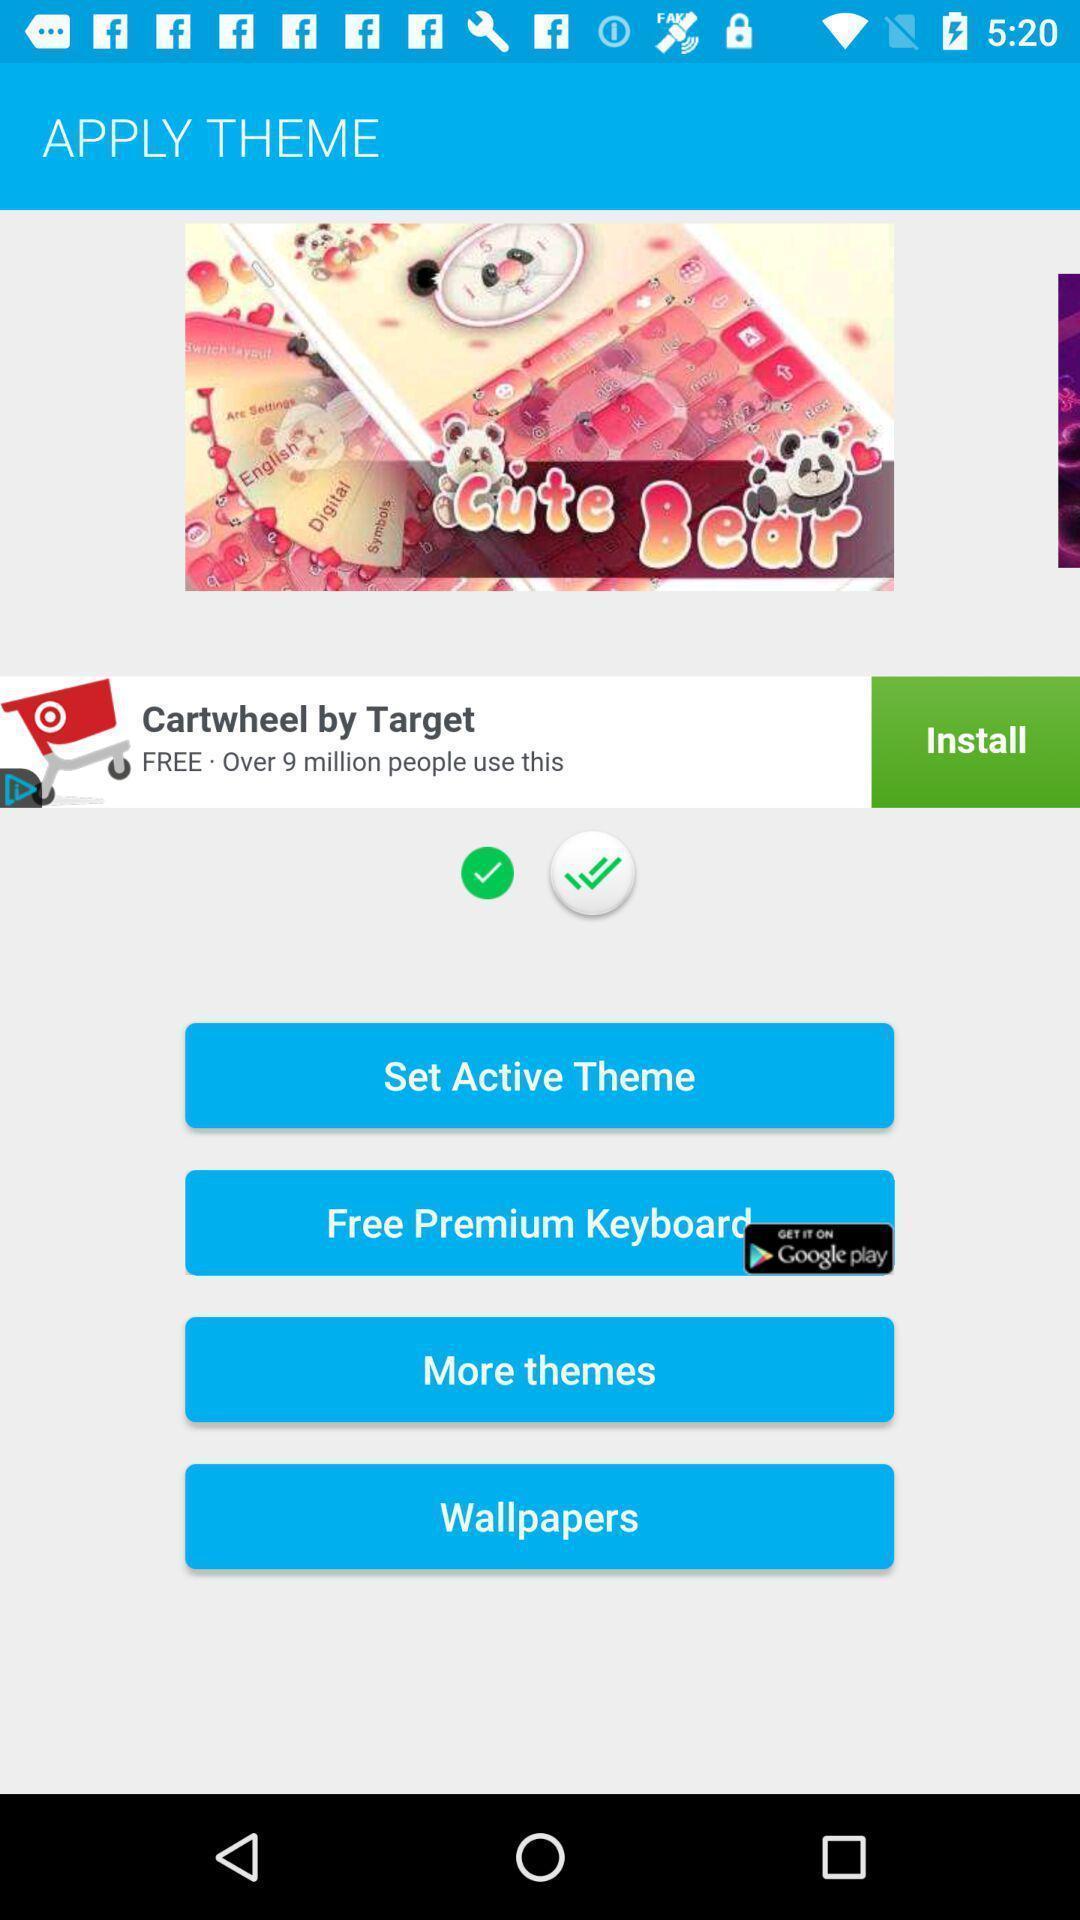What can you discern from this picture? Page displays to apply theme in app. 